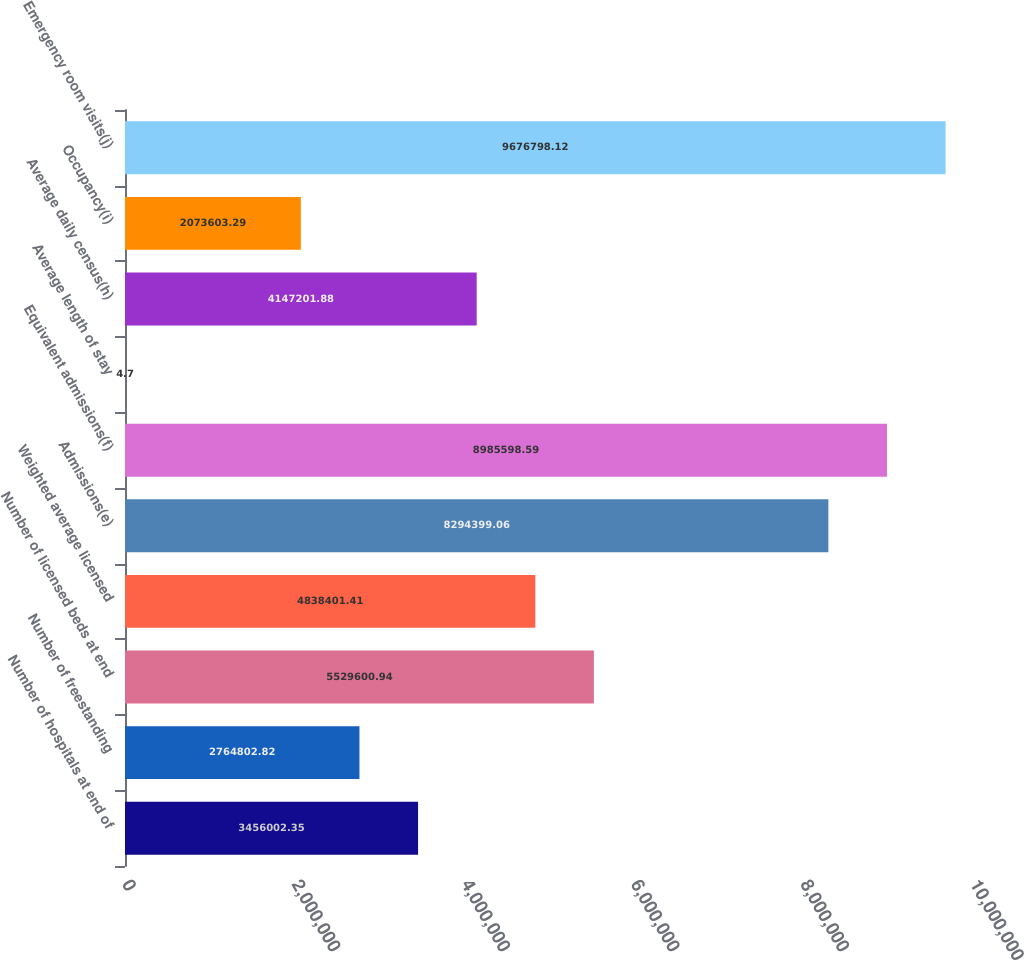Convert chart. <chart><loc_0><loc_0><loc_500><loc_500><bar_chart><fcel>Number of hospitals at end of<fcel>Number of freestanding<fcel>Number of licensed beds at end<fcel>Weighted average licensed<fcel>Admissions(e)<fcel>Equivalent admissions(f)<fcel>Average length of stay<fcel>Average daily census(h)<fcel>Occupancy(i)<fcel>Emergency room visits(j)<nl><fcel>3.456e+06<fcel>2.7648e+06<fcel>5.5296e+06<fcel>4.8384e+06<fcel>8.2944e+06<fcel>8.9856e+06<fcel>4.7<fcel>4.1472e+06<fcel>2.0736e+06<fcel>9.6768e+06<nl></chart> 